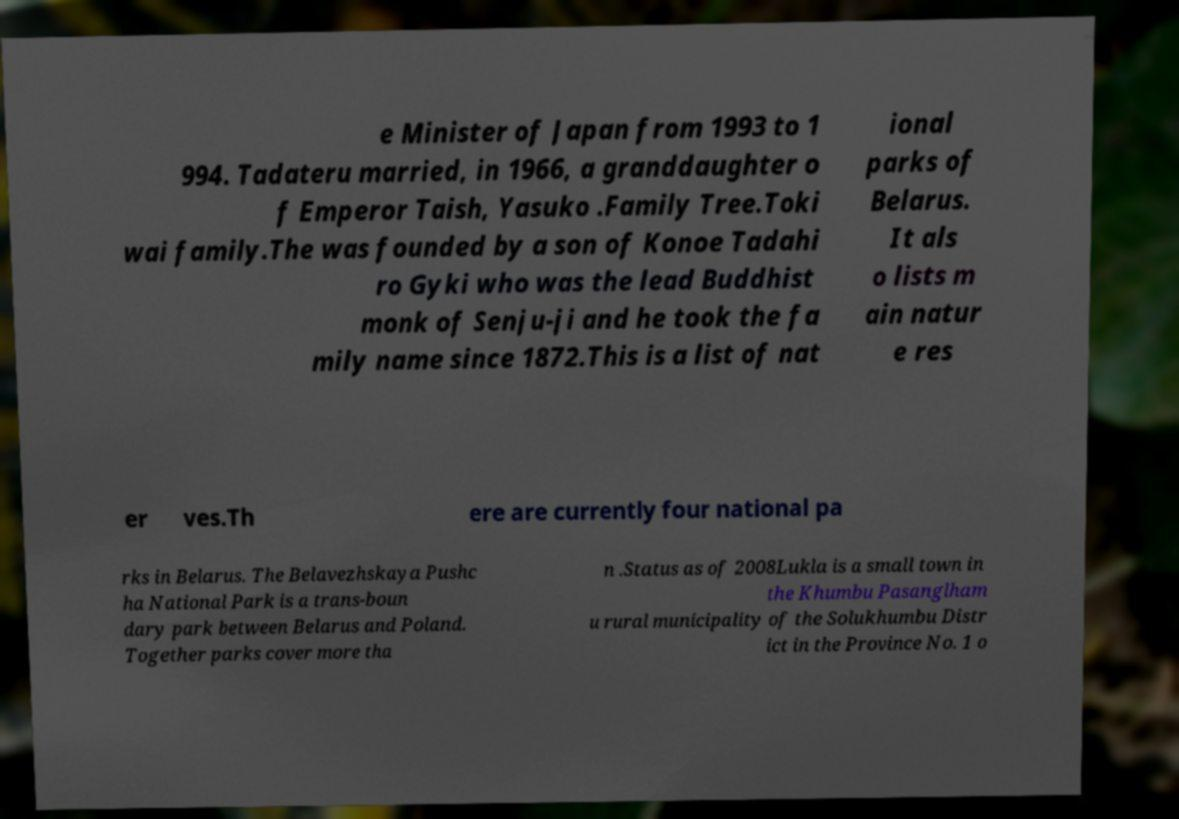What messages or text are displayed in this image? I need them in a readable, typed format. e Minister of Japan from 1993 to 1 994. Tadateru married, in 1966, a granddaughter o f Emperor Taish, Yasuko .Family Tree.Toki wai family.The was founded by a son of Konoe Tadahi ro Gyki who was the lead Buddhist monk of Senju-ji and he took the fa mily name since 1872.This is a list of nat ional parks of Belarus. It als o lists m ain natur e res er ves.Th ere are currently four national pa rks in Belarus. The Belavezhskaya Pushc ha National Park is a trans-boun dary park between Belarus and Poland. Together parks cover more tha n .Status as of 2008Lukla is a small town in the Khumbu Pasanglham u rural municipality of the Solukhumbu Distr ict in the Province No. 1 o 